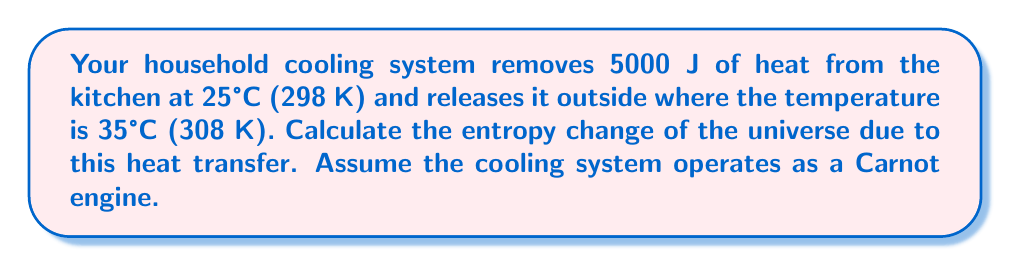Provide a solution to this math problem. Let's approach this step-by-step:

1) In a Carnot cycle, the entropy change of the universe is given by:

   $$\Delta S_{universe} = \Delta S_{kitchen} + \Delta S_{outside}$$

2) For the kitchen (cold reservoir):
   $$\Delta S_{kitchen} = -\frac{Q_c}{T_c}$$
   Where $Q_c$ is the heat removed and $T_c$ is the temperature of the kitchen.

3) For outside (hot reservoir):
   $$\Delta S_{outside} = \frac{Q_h}{T_h}$$
   Where $Q_h$ is the heat released and $T_h$ is the outside temperature.

4) In a Carnot cycle, $\frac{Q_c}{T_c} = \frac{Q_h}{T_h}$, so $Q_h = Q_c \cdot \frac{T_h}{T_c}$

5) Substituting the values:
   $$\Delta S_{kitchen} = -\frac{5000 \text{ J}}{298 \text{ K}} = -16.78 \text{ J/K}$$
   $$Q_h = 5000 \text{ J} \cdot \frac{308 \text{ K}}{298 \text{ K}} = 5167.79 \text{ J}$$
   $$\Delta S_{outside} = \frac{5167.79 \text{ J}}{308 \text{ K}} = 16.78 \text{ J/K}$$

6) The total entropy change:
   $$\Delta S_{universe} = -16.78 \text{ J/K} + 16.78 \text{ J/K} = 0 \text{ J/K}$$
Answer: 0 J/K 